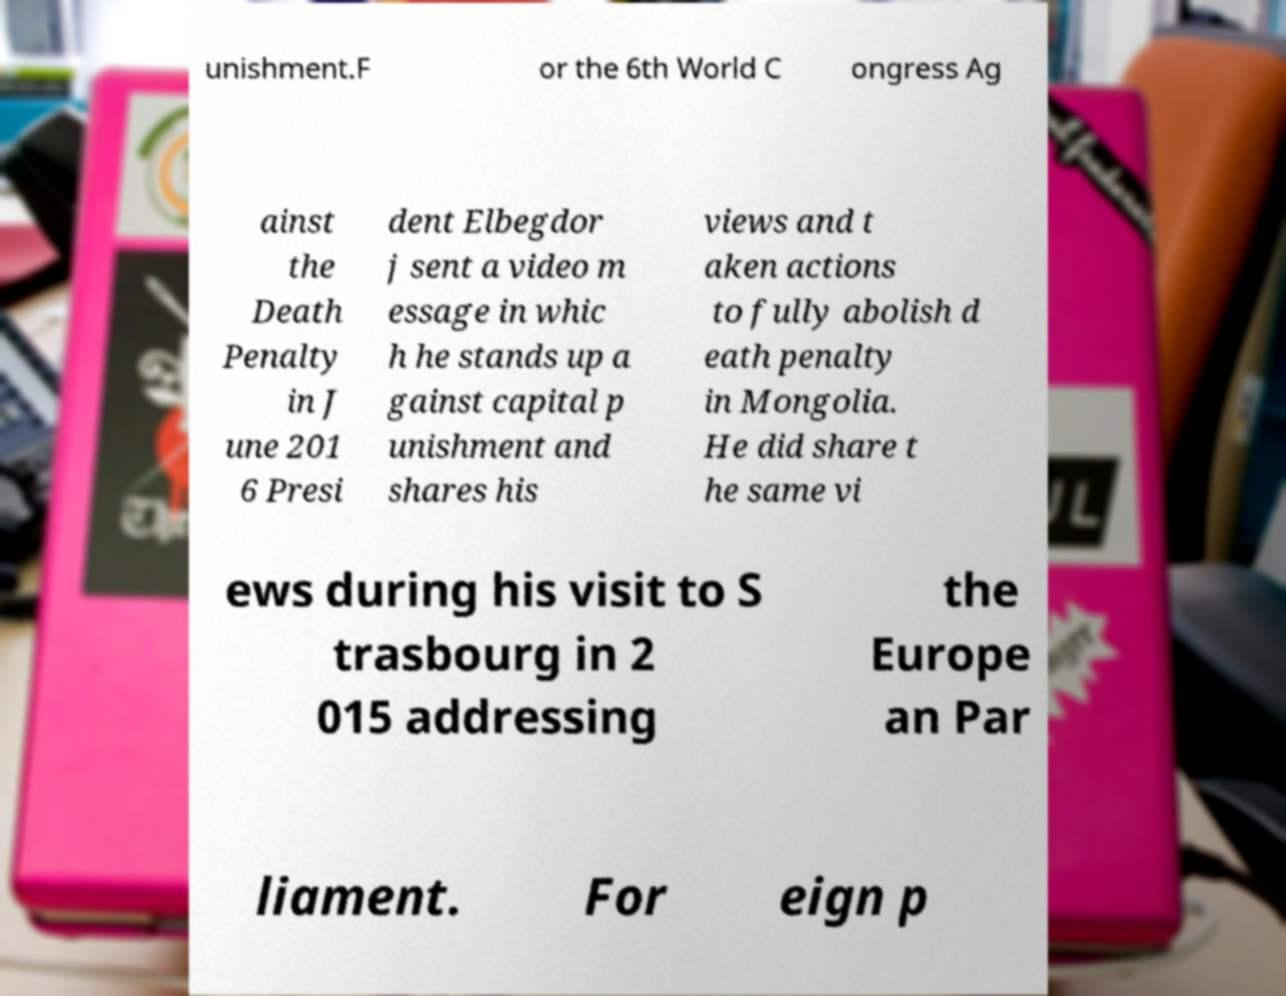Can you accurately transcribe the text from the provided image for me? unishment.F or the 6th World C ongress Ag ainst the Death Penalty in J une 201 6 Presi dent Elbegdor j sent a video m essage in whic h he stands up a gainst capital p unishment and shares his views and t aken actions to fully abolish d eath penalty in Mongolia. He did share t he same vi ews during his visit to S trasbourg in 2 015 addressing the Europe an Par liament. For eign p 